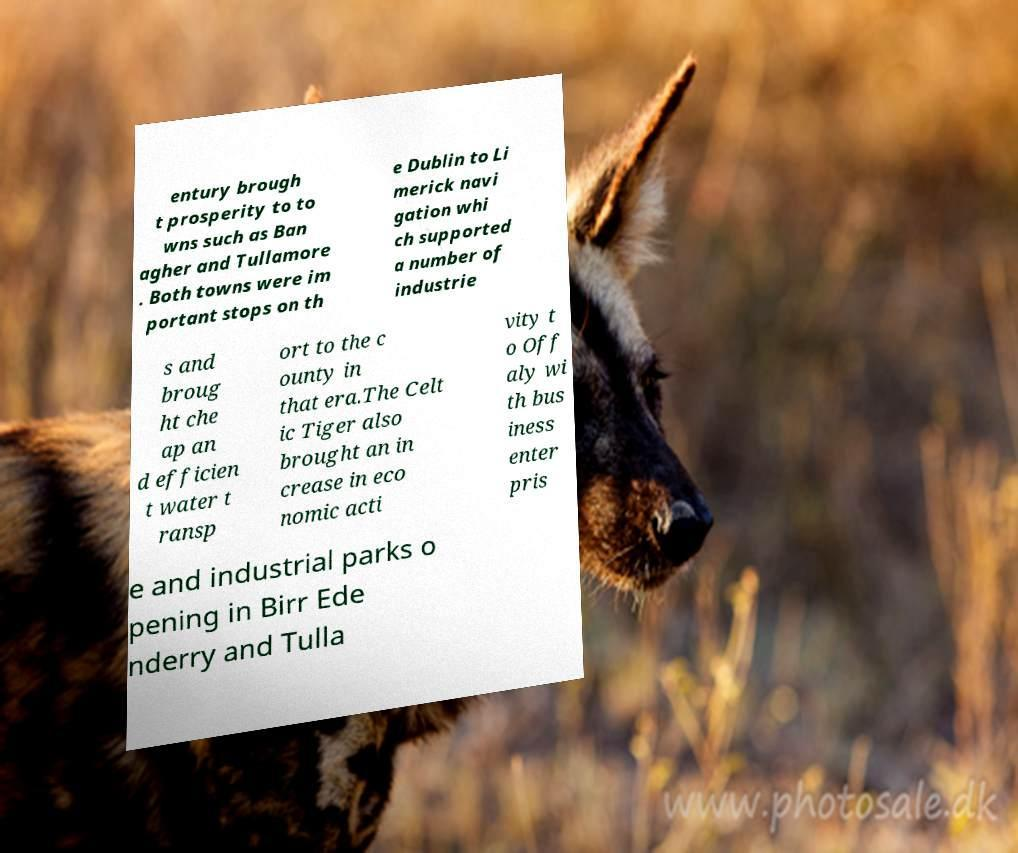For documentation purposes, I need the text within this image transcribed. Could you provide that? entury brough t prosperity to to wns such as Ban agher and Tullamore . Both towns were im portant stops on th e Dublin to Li merick navi gation whi ch supported a number of industrie s and broug ht che ap an d efficien t water t ransp ort to the c ounty in that era.The Celt ic Tiger also brought an in crease in eco nomic acti vity t o Off aly wi th bus iness enter pris e and industrial parks o pening in Birr Ede nderry and Tulla 